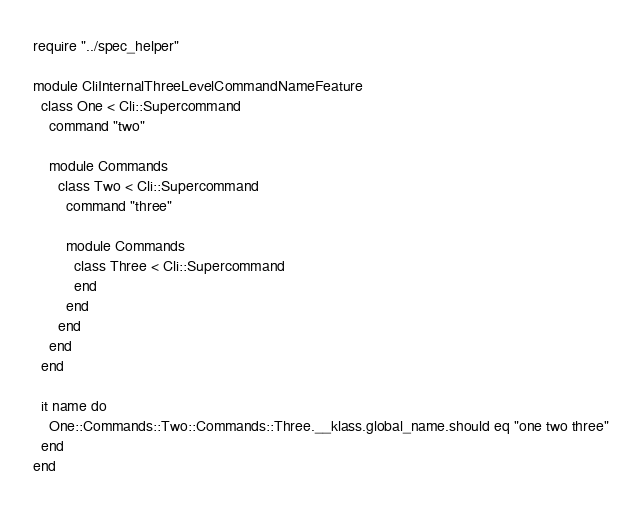Convert code to text. <code><loc_0><loc_0><loc_500><loc_500><_Crystal_>require "../spec_helper"

module CliInternalThreeLevelCommandNameFeature
  class One < Cli::Supercommand
    command "two"

    module Commands
      class Two < Cli::Supercommand
        command "three"

        module Commands
          class Three < Cli::Supercommand
          end
        end
      end
    end
  end

  it name do
    One::Commands::Two::Commands::Three.__klass.global_name.should eq "one two three"
  end
end
</code> 